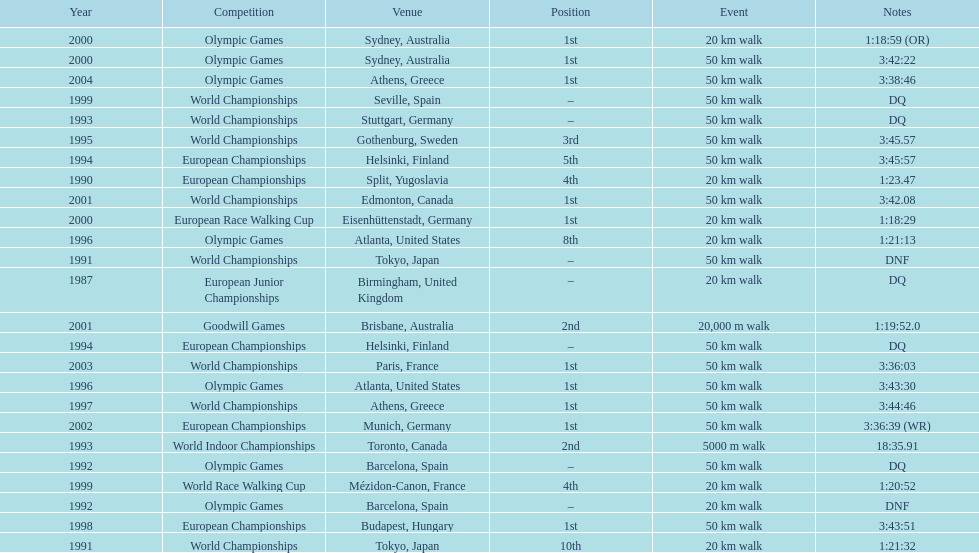How many events were at least 50 km? 17. 